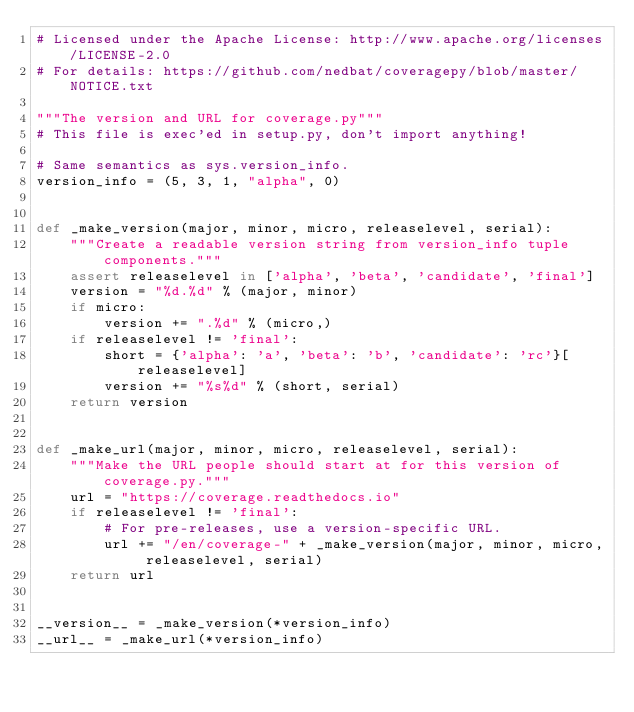<code> <loc_0><loc_0><loc_500><loc_500><_Python_># Licensed under the Apache License: http://www.apache.org/licenses/LICENSE-2.0
# For details: https://github.com/nedbat/coveragepy/blob/master/NOTICE.txt

"""The version and URL for coverage.py"""
# This file is exec'ed in setup.py, don't import anything!

# Same semantics as sys.version_info.
version_info = (5, 3, 1, "alpha", 0)


def _make_version(major, minor, micro, releaselevel, serial):
    """Create a readable version string from version_info tuple components."""
    assert releaselevel in ['alpha', 'beta', 'candidate', 'final']
    version = "%d.%d" % (major, minor)
    if micro:
        version += ".%d" % (micro,)
    if releaselevel != 'final':
        short = {'alpha': 'a', 'beta': 'b', 'candidate': 'rc'}[releaselevel]
        version += "%s%d" % (short, serial)
    return version


def _make_url(major, minor, micro, releaselevel, serial):
    """Make the URL people should start at for this version of coverage.py."""
    url = "https://coverage.readthedocs.io"
    if releaselevel != 'final':
        # For pre-releases, use a version-specific URL.
        url += "/en/coverage-" + _make_version(major, minor, micro, releaselevel, serial)
    return url


__version__ = _make_version(*version_info)
__url__ = _make_url(*version_info)
</code> 